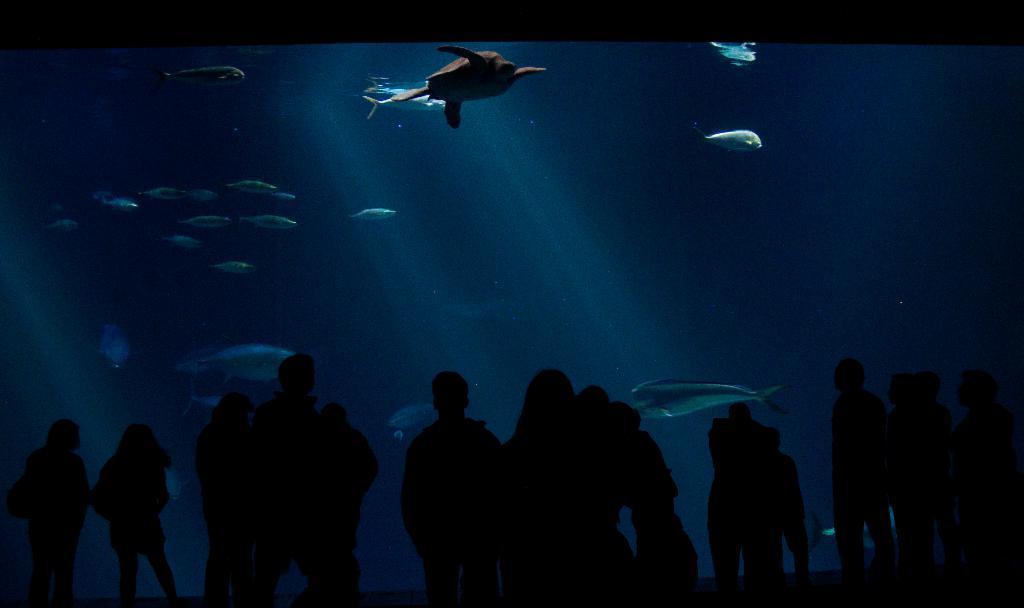Can you describe this image briefly? This picture is taken the dark where we can see these people are standing here. Here we can see the glass through which we can see tortoise and fishes are swimming in the water. 